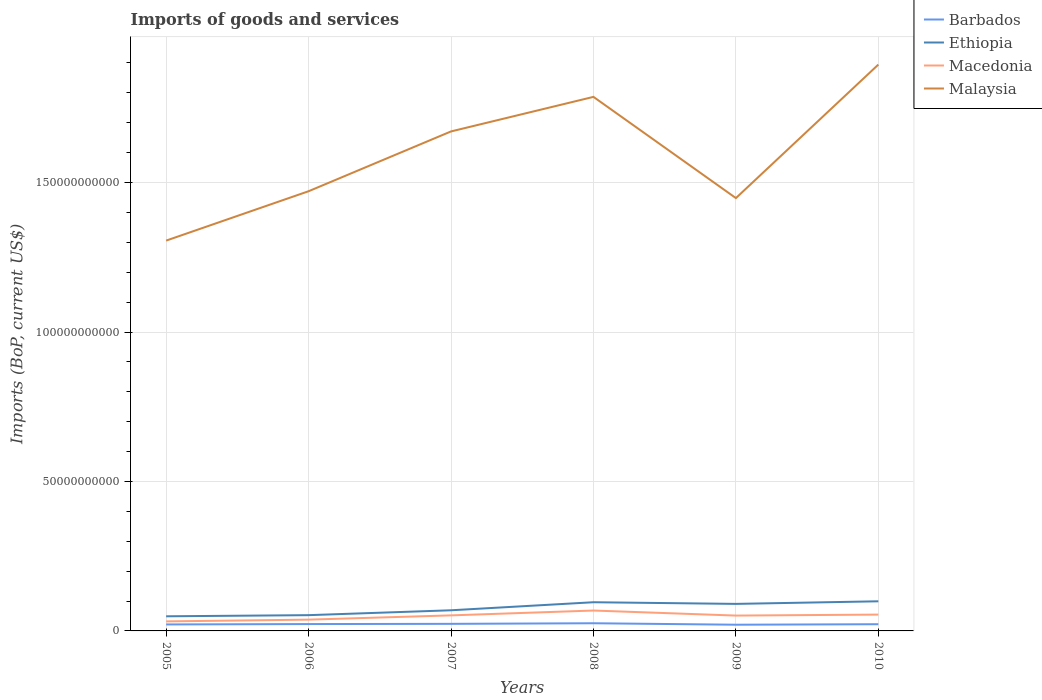How many different coloured lines are there?
Make the answer very short. 4. Does the line corresponding to Macedonia intersect with the line corresponding to Ethiopia?
Offer a terse response. No. Is the number of lines equal to the number of legend labels?
Make the answer very short. Yes. Across all years, what is the maximum amount spent on imports in Ethiopia?
Give a very brief answer. 4.89e+09. What is the total amount spent on imports in Malaysia in the graph?
Give a very brief answer. -2.00e+1. What is the difference between the highest and the second highest amount spent on imports in Malaysia?
Your answer should be compact. 5.89e+1. How many years are there in the graph?
Offer a very short reply. 6. What is the difference between two consecutive major ticks on the Y-axis?
Provide a short and direct response. 5.00e+1. Are the values on the major ticks of Y-axis written in scientific E-notation?
Make the answer very short. No. Does the graph contain any zero values?
Offer a very short reply. No. Does the graph contain grids?
Give a very brief answer. Yes. Where does the legend appear in the graph?
Provide a succinct answer. Top right. How many legend labels are there?
Keep it short and to the point. 4. What is the title of the graph?
Make the answer very short. Imports of goods and services. Does "Virgin Islands" appear as one of the legend labels in the graph?
Offer a very short reply. No. What is the label or title of the X-axis?
Offer a very short reply. Years. What is the label or title of the Y-axis?
Give a very brief answer. Imports (BoP, current US$). What is the Imports (BoP, current US$) in Barbados in 2005?
Your response must be concise. 2.17e+09. What is the Imports (BoP, current US$) in Ethiopia in 2005?
Your answer should be compact. 4.89e+09. What is the Imports (BoP, current US$) of Macedonia in 2005?
Ensure brevity in your answer.  3.19e+09. What is the Imports (BoP, current US$) of Malaysia in 2005?
Provide a short and direct response. 1.31e+11. What is the Imports (BoP, current US$) of Barbados in 2006?
Your answer should be very brief. 2.29e+09. What is the Imports (BoP, current US$) of Ethiopia in 2006?
Your answer should be compact. 5.28e+09. What is the Imports (BoP, current US$) of Macedonia in 2006?
Provide a short and direct response. 3.77e+09. What is the Imports (BoP, current US$) in Malaysia in 2006?
Your response must be concise. 1.47e+11. What is the Imports (BoP, current US$) of Barbados in 2007?
Your answer should be compact. 2.37e+09. What is the Imports (BoP, current US$) of Ethiopia in 2007?
Your response must be concise. 6.90e+09. What is the Imports (BoP, current US$) in Macedonia in 2007?
Provide a short and direct response. 5.20e+09. What is the Imports (BoP, current US$) of Malaysia in 2007?
Offer a very short reply. 1.67e+11. What is the Imports (BoP, current US$) of Barbados in 2008?
Provide a short and direct response. 2.57e+09. What is the Imports (BoP, current US$) of Ethiopia in 2008?
Keep it short and to the point. 9.60e+09. What is the Imports (BoP, current US$) of Macedonia in 2008?
Provide a succinct answer. 6.82e+09. What is the Imports (BoP, current US$) in Malaysia in 2008?
Your answer should be very brief. 1.79e+11. What is the Imports (BoP, current US$) of Barbados in 2009?
Offer a terse response. 2.08e+09. What is the Imports (BoP, current US$) in Ethiopia in 2009?
Offer a very short reply. 9.04e+09. What is the Imports (BoP, current US$) of Macedonia in 2009?
Provide a short and direct response. 5.13e+09. What is the Imports (BoP, current US$) of Malaysia in 2009?
Your response must be concise. 1.45e+11. What is the Imports (BoP, current US$) in Barbados in 2010?
Ensure brevity in your answer.  2.24e+09. What is the Imports (BoP, current US$) of Ethiopia in 2010?
Provide a succinct answer. 9.91e+09. What is the Imports (BoP, current US$) of Macedonia in 2010?
Make the answer very short. 5.46e+09. What is the Imports (BoP, current US$) in Malaysia in 2010?
Offer a very short reply. 1.89e+11. Across all years, what is the maximum Imports (BoP, current US$) in Barbados?
Your response must be concise. 2.57e+09. Across all years, what is the maximum Imports (BoP, current US$) in Ethiopia?
Provide a succinct answer. 9.91e+09. Across all years, what is the maximum Imports (BoP, current US$) of Macedonia?
Your answer should be compact. 6.82e+09. Across all years, what is the maximum Imports (BoP, current US$) in Malaysia?
Your response must be concise. 1.89e+11. Across all years, what is the minimum Imports (BoP, current US$) of Barbados?
Keep it short and to the point. 2.08e+09. Across all years, what is the minimum Imports (BoP, current US$) of Ethiopia?
Ensure brevity in your answer.  4.89e+09. Across all years, what is the minimum Imports (BoP, current US$) of Macedonia?
Ensure brevity in your answer.  3.19e+09. Across all years, what is the minimum Imports (BoP, current US$) in Malaysia?
Make the answer very short. 1.31e+11. What is the total Imports (BoP, current US$) in Barbados in the graph?
Offer a terse response. 1.37e+1. What is the total Imports (BoP, current US$) in Ethiopia in the graph?
Ensure brevity in your answer.  4.56e+1. What is the total Imports (BoP, current US$) of Macedonia in the graph?
Your answer should be very brief. 2.96e+1. What is the total Imports (BoP, current US$) in Malaysia in the graph?
Your answer should be compact. 9.58e+11. What is the difference between the Imports (BoP, current US$) in Barbados in 2005 and that in 2006?
Ensure brevity in your answer.  -1.23e+08. What is the difference between the Imports (BoP, current US$) of Ethiopia in 2005 and that in 2006?
Your answer should be very brief. -3.81e+08. What is the difference between the Imports (BoP, current US$) in Macedonia in 2005 and that in 2006?
Your answer should be very brief. -5.85e+08. What is the difference between the Imports (BoP, current US$) of Malaysia in 2005 and that in 2006?
Give a very brief answer. -1.65e+1. What is the difference between the Imports (BoP, current US$) of Barbados in 2005 and that in 2007?
Keep it short and to the point. -1.97e+08. What is the difference between the Imports (BoP, current US$) in Ethiopia in 2005 and that in 2007?
Give a very brief answer. -2.01e+09. What is the difference between the Imports (BoP, current US$) of Macedonia in 2005 and that in 2007?
Offer a very short reply. -2.01e+09. What is the difference between the Imports (BoP, current US$) of Malaysia in 2005 and that in 2007?
Keep it short and to the point. -3.65e+1. What is the difference between the Imports (BoP, current US$) of Barbados in 2005 and that in 2008?
Your answer should be very brief. -3.97e+08. What is the difference between the Imports (BoP, current US$) of Ethiopia in 2005 and that in 2008?
Your answer should be very brief. -4.70e+09. What is the difference between the Imports (BoP, current US$) of Macedonia in 2005 and that in 2008?
Your answer should be very brief. -3.63e+09. What is the difference between the Imports (BoP, current US$) in Malaysia in 2005 and that in 2008?
Ensure brevity in your answer.  -4.81e+1. What is the difference between the Imports (BoP, current US$) in Barbados in 2005 and that in 2009?
Ensure brevity in your answer.  9.44e+07. What is the difference between the Imports (BoP, current US$) in Ethiopia in 2005 and that in 2009?
Your answer should be compact. -4.15e+09. What is the difference between the Imports (BoP, current US$) in Macedonia in 2005 and that in 2009?
Offer a terse response. -1.94e+09. What is the difference between the Imports (BoP, current US$) of Malaysia in 2005 and that in 2009?
Provide a short and direct response. -1.42e+1. What is the difference between the Imports (BoP, current US$) of Barbados in 2005 and that in 2010?
Provide a succinct answer. -6.91e+07. What is the difference between the Imports (BoP, current US$) of Ethiopia in 2005 and that in 2010?
Give a very brief answer. -5.02e+09. What is the difference between the Imports (BoP, current US$) in Macedonia in 2005 and that in 2010?
Your response must be concise. -2.28e+09. What is the difference between the Imports (BoP, current US$) in Malaysia in 2005 and that in 2010?
Your answer should be very brief. -5.89e+1. What is the difference between the Imports (BoP, current US$) of Barbados in 2006 and that in 2007?
Your answer should be very brief. -7.39e+07. What is the difference between the Imports (BoP, current US$) of Ethiopia in 2006 and that in 2007?
Your answer should be very brief. -1.63e+09. What is the difference between the Imports (BoP, current US$) of Macedonia in 2006 and that in 2007?
Ensure brevity in your answer.  -1.43e+09. What is the difference between the Imports (BoP, current US$) of Malaysia in 2006 and that in 2007?
Provide a succinct answer. -2.00e+1. What is the difference between the Imports (BoP, current US$) of Barbados in 2006 and that in 2008?
Your answer should be very brief. -2.74e+08. What is the difference between the Imports (BoP, current US$) of Ethiopia in 2006 and that in 2008?
Your answer should be very brief. -4.32e+09. What is the difference between the Imports (BoP, current US$) of Macedonia in 2006 and that in 2008?
Provide a short and direct response. -3.05e+09. What is the difference between the Imports (BoP, current US$) of Malaysia in 2006 and that in 2008?
Provide a succinct answer. -3.16e+1. What is the difference between the Imports (BoP, current US$) in Barbados in 2006 and that in 2009?
Your answer should be compact. 2.17e+08. What is the difference between the Imports (BoP, current US$) in Ethiopia in 2006 and that in 2009?
Provide a succinct answer. -3.77e+09. What is the difference between the Imports (BoP, current US$) of Macedonia in 2006 and that in 2009?
Your answer should be very brief. -1.36e+09. What is the difference between the Imports (BoP, current US$) of Malaysia in 2006 and that in 2009?
Your answer should be compact. 2.30e+09. What is the difference between the Imports (BoP, current US$) of Barbados in 2006 and that in 2010?
Keep it short and to the point. 5.40e+07. What is the difference between the Imports (BoP, current US$) of Ethiopia in 2006 and that in 2010?
Keep it short and to the point. -4.63e+09. What is the difference between the Imports (BoP, current US$) in Macedonia in 2006 and that in 2010?
Provide a short and direct response. -1.69e+09. What is the difference between the Imports (BoP, current US$) in Malaysia in 2006 and that in 2010?
Your response must be concise. -4.24e+1. What is the difference between the Imports (BoP, current US$) in Barbados in 2007 and that in 2008?
Your answer should be compact. -2.00e+08. What is the difference between the Imports (BoP, current US$) of Ethiopia in 2007 and that in 2008?
Your response must be concise. -2.69e+09. What is the difference between the Imports (BoP, current US$) of Macedonia in 2007 and that in 2008?
Offer a very short reply. -1.62e+09. What is the difference between the Imports (BoP, current US$) of Malaysia in 2007 and that in 2008?
Provide a short and direct response. -1.16e+1. What is the difference between the Imports (BoP, current US$) of Barbados in 2007 and that in 2009?
Your response must be concise. 2.91e+08. What is the difference between the Imports (BoP, current US$) of Ethiopia in 2007 and that in 2009?
Provide a short and direct response. -2.14e+09. What is the difference between the Imports (BoP, current US$) in Macedonia in 2007 and that in 2009?
Offer a terse response. 6.79e+07. What is the difference between the Imports (BoP, current US$) in Malaysia in 2007 and that in 2009?
Provide a short and direct response. 2.23e+1. What is the difference between the Imports (BoP, current US$) of Barbados in 2007 and that in 2010?
Your response must be concise. 1.28e+08. What is the difference between the Imports (BoP, current US$) in Ethiopia in 2007 and that in 2010?
Offer a terse response. -3.01e+09. What is the difference between the Imports (BoP, current US$) in Macedonia in 2007 and that in 2010?
Ensure brevity in your answer.  -2.63e+08. What is the difference between the Imports (BoP, current US$) of Malaysia in 2007 and that in 2010?
Provide a succinct answer. -2.24e+1. What is the difference between the Imports (BoP, current US$) of Barbados in 2008 and that in 2009?
Ensure brevity in your answer.  4.92e+08. What is the difference between the Imports (BoP, current US$) in Ethiopia in 2008 and that in 2009?
Offer a very short reply. 5.55e+08. What is the difference between the Imports (BoP, current US$) of Macedonia in 2008 and that in 2009?
Offer a terse response. 1.69e+09. What is the difference between the Imports (BoP, current US$) of Malaysia in 2008 and that in 2009?
Provide a short and direct response. 3.39e+1. What is the difference between the Imports (BoP, current US$) in Barbados in 2008 and that in 2010?
Give a very brief answer. 3.28e+08. What is the difference between the Imports (BoP, current US$) in Ethiopia in 2008 and that in 2010?
Your answer should be very brief. -3.13e+08. What is the difference between the Imports (BoP, current US$) of Macedonia in 2008 and that in 2010?
Keep it short and to the point. 1.36e+09. What is the difference between the Imports (BoP, current US$) of Malaysia in 2008 and that in 2010?
Make the answer very short. -1.08e+1. What is the difference between the Imports (BoP, current US$) of Barbados in 2009 and that in 2010?
Your response must be concise. -1.63e+08. What is the difference between the Imports (BoP, current US$) of Ethiopia in 2009 and that in 2010?
Provide a succinct answer. -8.68e+08. What is the difference between the Imports (BoP, current US$) of Macedonia in 2009 and that in 2010?
Make the answer very short. -3.31e+08. What is the difference between the Imports (BoP, current US$) in Malaysia in 2009 and that in 2010?
Provide a short and direct response. -4.47e+1. What is the difference between the Imports (BoP, current US$) in Barbados in 2005 and the Imports (BoP, current US$) in Ethiopia in 2006?
Provide a short and direct response. -3.10e+09. What is the difference between the Imports (BoP, current US$) in Barbados in 2005 and the Imports (BoP, current US$) in Macedonia in 2006?
Offer a very short reply. -1.60e+09. What is the difference between the Imports (BoP, current US$) in Barbados in 2005 and the Imports (BoP, current US$) in Malaysia in 2006?
Ensure brevity in your answer.  -1.45e+11. What is the difference between the Imports (BoP, current US$) of Ethiopia in 2005 and the Imports (BoP, current US$) of Macedonia in 2006?
Offer a terse response. 1.12e+09. What is the difference between the Imports (BoP, current US$) of Ethiopia in 2005 and the Imports (BoP, current US$) of Malaysia in 2006?
Your answer should be very brief. -1.42e+11. What is the difference between the Imports (BoP, current US$) of Macedonia in 2005 and the Imports (BoP, current US$) of Malaysia in 2006?
Provide a short and direct response. -1.44e+11. What is the difference between the Imports (BoP, current US$) of Barbados in 2005 and the Imports (BoP, current US$) of Ethiopia in 2007?
Your answer should be very brief. -4.73e+09. What is the difference between the Imports (BoP, current US$) in Barbados in 2005 and the Imports (BoP, current US$) in Macedonia in 2007?
Your answer should be very brief. -3.03e+09. What is the difference between the Imports (BoP, current US$) in Barbados in 2005 and the Imports (BoP, current US$) in Malaysia in 2007?
Make the answer very short. -1.65e+11. What is the difference between the Imports (BoP, current US$) of Ethiopia in 2005 and the Imports (BoP, current US$) of Macedonia in 2007?
Make the answer very short. -3.05e+08. What is the difference between the Imports (BoP, current US$) of Ethiopia in 2005 and the Imports (BoP, current US$) of Malaysia in 2007?
Make the answer very short. -1.62e+11. What is the difference between the Imports (BoP, current US$) of Macedonia in 2005 and the Imports (BoP, current US$) of Malaysia in 2007?
Your answer should be compact. -1.64e+11. What is the difference between the Imports (BoP, current US$) in Barbados in 2005 and the Imports (BoP, current US$) in Ethiopia in 2008?
Provide a short and direct response. -7.43e+09. What is the difference between the Imports (BoP, current US$) of Barbados in 2005 and the Imports (BoP, current US$) of Macedonia in 2008?
Provide a short and direct response. -4.65e+09. What is the difference between the Imports (BoP, current US$) in Barbados in 2005 and the Imports (BoP, current US$) in Malaysia in 2008?
Keep it short and to the point. -1.76e+11. What is the difference between the Imports (BoP, current US$) of Ethiopia in 2005 and the Imports (BoP, current US$) of Macedonia in 2008?
Ensure brevity in your answer.  -1.92e+09. What is the difference between the Imports (BoP, current US$) in Ethiopia in 2005 and the Imports (BoP, current US$) in Malaysia in 2008?
Offer a terse response. -1.74e+11. What is the difference between the Imports (BoP, current US$) in Macedonia in 2005 and the Imports (BoP, current US$) in Malaysia in 2008?
Your answer should be very brief. -1.75e+11. What is the difference between the Imports (BoP, current US$) in Barbados in 2005 and the Imports (BoP, current US$) in Ethiopia in 2009?
Provide a short and direct response. -6.87e+09. What is the difference between the Imports (BoP, current US$) of Barbados in 2005 and the Imports (BoP, current US$) of Macedonia in 2009?
Provide a succinct answer. -2.96e+09. What is the difference between the Imports (BoP, current US$) of Barbados in 2005 and the Imports (BoP, current US$) of Malaysia in 2009?
Your answer should be compact. -1.43e+11. What is the difference between the Imports (BoP, current US$) of Ethiopia in 2005 and the Imports (BoP, current US$) of Macedonia in 2009?
Your answer should be compact. -2.37e+08. What is the difference between the Imports (BoP, current US$) of Ethiopia in 2005 and the Imports (BoP, current US$) of Malaysia in 2009?
Give a very brief answer. -1.40e+11. What is the difference between the Imports (BoP, current US$) in Macedonia in 2005 and the Imports (BoP, current US$) in Malaysia in 2009?
Provide a short and direct response. -1.42e+11. What is the difference between the Imports (BoP, current US$) of Barbados in 2005 and the Imports (BoP, current US$) of Ethiopia in 2010?
Provide a succinct answer. -7.74e+09. What is the difference between the Imports (BoP, current US$) in Barbados in 2005 and the Imports (BoP, current US$) in Macedonia in 2010?
Offer a very short reply. -3.29e+09. What is the difference between the Imports (BoP, current US$) of Barbados in 2005 and the Imports (BoP, current US$) of Malaysia in 2010?
Ensure brevity in your answer.  -1.87e+11. What is the difference between the Imports (BoP, current US$) of Ethiopia in 2005 and the Imports (BoP, current US$) of Macedonia in 2010?
Offer a very short reply. -5.69e+08. What is the difference between the Imports (BoP, current US$) in Ethiopia in 2005 and the Imports (BoP, current US$) in Malaysia in 2010?
Provide a short and direct response. -1.85e+11. What is the difference between the Imports (BoP, current US$) of Macedonia in 2005 and the Imports (BoP, current US$) of Malaysia in 2010?
Ensure brevity in your answer.  -1.86e+11. What is the difference between the Imports (BoP, current US$) in Barbados in 2006 and the Imports (BoP, current US$) in Ethiopia in 2007?
Offer a very short reply. -4.61e+09. What is the difference between the Imports (BoP, current US$) of Barbados in 2006 and the Imports (BoP, current US$) of Macedonia in 2007?
Offer a terse response. -2.91e+09. What is the difference between the Imports (BoP, current US$) of Barbados in 2006 and the Imports (BoP, current US$) of Malaysia in 2007?
Your answer should be very brief. -1.65e+11. What is the difference between the Imports (BoP, current US$) of Ethiopia in 2006 and the Imports (BoP, current US$) of Macedonia in 2007?
Your answer should be very brief. 7.60e+07. What is the difference between the Imports (BoP, current US$) of Ethiopia in 2006 and the Imports (BoP, current US$) of Malaysia in 2007?
Your answer should be compact. -1.62e+11. What is the difference between the Imports (BoP, current US$) of Macedonia in 2006 and the Imports (BoP, current US$) of Malaysia in 2007?
Give a very brief answer. -1.63e+11. What is the difference between the Imports (BoP, current US$) in Barbados in 2006 and the Imports (BoP, current US$) in Ethiopia in 2008?
Offer a very short reply. -7.30e+09. What is the difference between the Imports (BoP, current US$) in Barbados in 2006 and the Imports (BoP, current US$) in Macedonia in 2008?
Ensure brevity in your answer.  -4.53e+09. What is the difference between the Imports (BoP, current US$) in Barbados in 2006 and the Imports (BoP, current US$) in Malaysia in 2008?
Provide a succinct answer. -1.76e+11. What is the difference between the Imports (BoP, current US$) of Ethiopia in 2006 and the Imports (BoP, current US$) of Macedonia in 2008?
Keep it short and to the point. -1.54e+09. What is the difference between the Imports (BoP, current US$) in Ethiopia in 2006 and the Imports (BoP, current US$) in Malaysia in 2008?
Keep it short and to the point. -1.73e+11. What is the difference between the Imports (BoP, current US$) of Macedonia in 2006 and the Imports (BoP, current US$) of Malaysia in 2008?
Make the answer very short. -1.75e+11. What is the difference between the Imports (BoP, current US$) in Barbados in 2006 and the Imports (BoP, current US$) in Ethiopia in 2009?
Make the answer very short. -6.75e+09. What is the difference between the Imports (BoP, current US$) of Barbados in 2006 and the Imports (BoP, current US$) of Macedonia in 2009?
Offer a very short reply. -2.84e+09. What is the difference between the Imports (BoP, current US$) of Barbados in 2006 and the Imports (BoP, current US$) of Malaysia in 2009?
Keep it short and to the point. -1.43e+11. What is the difference between the Imports (BoP, current US$) in Ethiopia in 2006 and the Imports (BoP, current US$) in Macedonia in 2009?
Keep it short and to the point. 1.44e+08. What is the difference between the Imports (BoP, current US$) in Ethiopia in 2006 and the Imports (BoP, current US$) in Malaysia in 2009?
Your answer should be compact. -1.40e+11. What is the difference between the Imports (BoP, current US$) in Macedonia in 2006 and the Imports (BoP, current US$) in Malaysia in 2009?
Your answer should be very brief. -1.41e+11. What is the difference between the Imports (BoP, current US$) in Barbados in 2006 and the Imports (BoP, current US$) in Ethiopia in 2010?
Your answer should be compact. -7.62e+09. What is the difference between the Imports (BoP, current US$) of Barbados in 2006 and the Imports (BoP, current US$) of Macedonia in 2010?
Your answer should be compact. -3.17e+09. What is the difference between the Imports (BoP, current US$) in Barbados in 2006 and the Imports (BoP, current US$) in Malaysia in 2010?
Make the answer very short. -1.87e+11. What is the difference between the Imports (BoP, current US$) in Ethiopia in 2006 and the Imports (BoP, current US$) in Macedonia in 2010?
Make the answer very short. -1.87e+08. What is the difference between the Imports (BoP, current US$) of Ethiopia in 2006 and the Imports (BoP, current US$) of Malaysia in 2010?
Your response must be concise. -1.84e+11. What is the difference between the Imports (BoP, current US$) of Macedonia in 2006 and the Imports (BoP, current US$) of Malaysia in 2010?
Provide a short and direct response. -1.86e+11. What is the difference between the Imports (BoP, current US$) of Barbados in 2007 and the Imports (BoP, current US$) of Ethiopia in 2008?
Provide a short and direct response. -7.23e+09. What is the difference between the Imports (BoP, current US$) of Barbados in 2007 and the Imports (BoP, current US$) of Macedonia in 2008?
Your answer should be very brief. -4.45e+09. What is the difference between the Imports (BoP, current US$) in Barbados in 2007 and the Imports (BoP, current US$) in Malaysia in 2008?
Ensure brevity in your answer.  -1.76e+11. What is the difference between the Imports (BoP, current US$) in Ethiopia in 2007 and the Imports (BoP, current US$) in Macedonia in 2008?
Your answer should be very brief. 8.50e+07. What is the difference between the Imports (BoP, current US$) in Ethiopia in 2007 and the Imports (BoP, current US$) in Malaysia in 2008?
Your response must be concise. -1.72e+11. What is the difference between the Imports (BoP, current US$) in Macedonia in 2007 and the Imports (BoP, current US$) in Malaysia in 2008?
Your answer should be very brief. -1.73e+11. What is the difference between the Imports (BoP, current US$) of Barbados in 2007 and the Imports (BoP, current US$) of Ethiopia in 2009?
Your answer should be very brief. -6.67e+09. What is the difference between the Imports (BoP, current US$) of Barbados in 2007 and the Imports (BoP, current US$) of Macedonia in 2009?
Your answer should be very brief. -2.76e+09. What is the difference between the Imports (BoP, current US$) in Barbados in 2007 and the Imports (BoP, current US$) in Malaysia in 2009?
Ensure brevity in your answer.  -1.42e+11. What is the difference between the Imports (BoP, current US$) of Ethiopia in 2007 and the Imports (BoP, current US$) of Macedonia in 2009?
Keep it short and to the point. 1.77e+09. What is the difference between the Imports (BoP, current US$) of Ethiopia in 2007 and the Imports (BoP, current US$) of Malaysia in 2009?
Your answer should be very brief. -1.38e+11. What is the difference between the Imports (BoP, current US$) in Macedonia in 2007 and the Imports (BoP, current US$) in Malaysia in 2009?
Make the answer very short. -1.40e+11. What is the difference between the Imports (BoP, current US$) in Barbados in 2007 and the Imports (BoP, current US$) in Ethiopia in 2010?
Keep it short and to the point. -7.54e+09. What is the difference between the Imports (BoP, current US$) in Barbados in 2007 and the Imports (BoP, current US$) in Macedonia in 2010?
Provide a short and direct response. -3.10e+09. What is the difference between the Imports (BoP, current US$) of Barbados in 2007 and the Imports (BoP, current US$) of Malaysia in 2010?
Ensure brevity in your answer.  -1.87e+11. What is the difference between the Imports (BoP, current US$) in Ethiopia in 2007 and the Imports (BoP, current US$) in Macedonia in 2010?
Offer a terse response. 1.44e+09. What is the difference between the Imports (BoP, current US$) in Ethiopia in 2007 and the Imports (BoP, current US$) in Malaysia in 2010?
Your answer should be compact. -1.83e+11. What is the difference between the Imports (BoP, current US$) of Macedonia in 2007 and the Imports (BoP, current US$) of Malaysia in 2010?
Give a very brief answer. -1.84e+11. What is the difference between the Imports (BoP, current US$) of Barbados in 2008 and the Imports (BoP, current US$) of Ethiopia in 2009?
Give a very brief answer. -6.47e+09. What is the difference between the Imports (BoP, current US$) of Barbados in 2008 and the Imports (BoP, current US$) of Macedonia in 2009?
Provide a succinct answer. -2.56e+09. What is the difference between the Imports (BoP, current US$) of Barbados in 2008 and the Imports (BoP, current US$) of Malaysia in 2009?
Provide a succinct answer. -1.42e+11. What is the difference between the Imports (BoP, current US$) in Ethiopia in 2008 and the Imports (BoP, current US$) in Macedonia in 2009?
Your answer should be very brief. 4.47e+09. What is the difference between the Imports (BoP, current US$) in Ethiopia in 2008 and the Imports (BoP, current US$) in Malaysia in 2009?
Make the answer very short. -1.35e+11. What is the difference between the Imports (BoP, current US$) in Macedonia in 2008 and the Imports (BoP, current US$) in Malaysia in 2009?
Your response must be concise. -1.38e+11. What is the difference between the Imports (BoP, current US$) of Barbados in 2008 and the Imports (BoP, current US$) of Ethiopia in 2010?
Offer a very short reply. -7.34e+09. What is the difference between the Imports (BoP, current US$) of Barbados in 2008 and the Imports (BoP, current US$) of Macedonia in 2010?
Make the answer very short. -2.89e+09. What is the difference between the Imports (BoP, current US$) of Barbados in 2008 and the Imports (BoP, current US$) of Malaysia in 2010?
Provide a short and direct response. -1.87e+11. What is the difference between the Imports (BoP, current US$) in Ethiopia in 2008 and the Imports (BoP, current US$) in Macedonia in 2010?
Keep it short and to the point. 4.13e+09. What is the difference between the Imports (BoP, current US$) in Ethiopia in 2008 and the Imports (BoP, current US$) in Malaysia in 2010?
Your response must be concise. -1.80e+11. What is the difference between the Imports (BoP, current US$) of Macedonia in 2008 and the Imports (BoP, current US$) of Malaysia in 2010?
Provide a succinct answer. -1.83e+11. What is the difference between the Imports (BoP, current US$) of Barbados in 2009 and the Imports (BoP, current US$) of Ethiopia in 2010?
Provide a short and direct response. -7.83e+09. What is the difference between the Imports (BoP, current US$) in Barbados in 2009 and the Imports (BoP, current US$) in Macedonia in 2010?
Your answer should be compact. -3.39e+09. What is the difference between the Imports (BoP, current US$) in Barbados in 2009 and the Imports (BoP, current US$) in Malaysia in 2010?
Keep it short and to the point. -1.87e+11. What is the difference between the Imports (BoP, current US$) in Ethiopia in 2009 and the Imports (BoP, current US$) in Macedonia in 2010?
Keep it short and to the point. 3.58e+09. What is the difference between the Imports (BoP, current US$) in Ethiopia in 2009 and the Imports (BoP, current US$) in Malaysia in 2010?
Your answer should be compact. -1.80e+11. What is the difference between the Imports (BoP, current US$) of Macedonia in 2009 and the Imports (BoP, current US$) of Malaysia in 2010?
Your answer should be compact. -1.84e+11. What is the average Imports (BoP, current US$) of Barbados per year?
Your answer should be compact. 2.29e+09. What is the average Imports (BoP, current US$) in Ethiopia per year?
Ensure brevity in your answer.  7.60e+09. What is the average Imports (BoP, current US$) in Macedonia per year?
Offer a terse response. 4.93e+09. What is the average Imports (BoP, current US$) in Malaysia per year?
Provide a succinct answer. 1.60e+11. In the year 2005, what is the difference between the Imports (BoP, current US$) in Barbados and Imports (BoP, current US$) in Ethiopia?
Your answer should be compact. -2.72e+09. In the year 2005, what is the difference between the Imports (BoP, current US$) in Barbados and Imports (BoP, current US$) in Macedonia?
Keep it short and to the point. -1.02e+09. In the year 2005, what is the difference between the Imports (BoP, current US$) of Barbados and Imports (BoP, current US$) of Malaysia?
Offer a very short reply. -1.28e+11. In the year 2005, what is the difference between the Imports (BoP, current US$) of Ethiopia and Imports (BoP, current US$) of Macedonia?
Your response must be concise. 1.71e+09. In the year 2005, what is the difference between the Imports (BoP, current US$) in Ethiopia and Imports (BoP, current US$) in Malaysia?
Your response must be concise. -1.26e+11. In the year 2005, what is the difference between the Imports (BoP, current US$) in Macedonia and Imports (BoP, current US$) in Malaysia?
Your response must be concise. -1.27e+11. In the year 2006, what is the difference between the Imports (BoP, current US$) in Barbados and Imports (BoP, current US$) in Ethiopia?
Ensure brevity in your answer.  -2.98e+09. In the year 2006, what is the difference between the Imports (BoP, current US$) of Barbados and Imports (BoP, current US$) of Macedonia?
Your answer should be compact. -1.48e+09. In the year 2006, what is the difference between the Imports (BoP, current US$) of Barbados and Imports (BoP, current US$) of Malaysia?
Offer a terse response. -1.45e+11. In the year 2006, what is the difference between the Imports (BoP, current US$) of Ethiopia and Imports (BoP, current US$) of Macedonia?
Your response must be concise. 1.50e+09. In the year 2006, what is the difference between the Imports (BoP, current US$) in Ethiopia and Imports (BoP, current US$) in Malaysia?
Make the answer very short. -1.42e+11. In the year 2006, what is the difference between the Imports (BoP, current US$) of Macedonia and Imports (BoP, current US$) of Malaysia?
Ensure brevity in your answer.  -1.43e+11. In the year 2007, what is the difference between the Imports (BoP, current US$) in Barbados and Imports (BoP, current US$) in Ethiopia?
Your answer should be very brief. -4.54e+09. In the year 2007, what is the difference between the Imports (BoP, current US$) in Barbados and Imports (BoP, current US$) in Macedonia?
Provide a short and direct response. -2.83e+09. In the year 2007, what is the difference between the Imports (BoP, current US$) in Barbados and Imports (BoP, current US$) in Malaysia?
Your response must be concise. -1.65e+11. In the year 2007, what is the difference between the Imports (BoP, current US$) of Ethiopia and Imports (BoP, current US$) of Macedonia?
Offer a terse response. 1.70e+09. In the year 2007, what is the difference between the Imports (BoP, current US$) in Ethiopia and Imports (BoP, current US$) in Malaysia?
Your answer should be compact. -1.60e+11. In the year 2007, what is the difference between the Imports (BoP, current US$) of Macedonia and Imports (BoP, current US$) of Malaysia?
Provide a short and direct response. -1.62e+11. In the year 2008, what is the difference between the Imports (BoP, current US$) of Barbados and Imports (BoP, current US$) of Ethiopia?
Provide a succinct answer. -7.03e+09. In the year 2008, what is the difference between the Imports (BoP, current US$) in Barbados and Imports (BoP, current US$) in Macedonia?
Offer a very short reply. -4.25e+09. In the year 2008, what is the difference between the Imports (BoP, current US$) of Barbados and Imports (BoP, current US$) of Malaysia?
Your response must be concise. -1.76e+11. In the year 2008, what is the difference between the Imports (BoP, current US$) in Ethiopia and Imports (BoP, current US$) in Macedonia?
Make the answer very short. 2.78e+09. In the year 2008, what is the difference between the Imports (BoP, current US$) of Ethiopia and Imports (BoP, current US$) of Malaysia?
Your response must be concise. -1.69e+11. In the year 2008, what is the difference between the Imports (BoP, current US$) of Macedonia and Imports (BoP, current US$) of Malaysia?
Make the answer very short. -1.72e+11. In the year 2009, what is the difference between the Imports (BoP, current US$) in Barbados and Imports (BoP, current US$) in Ethiopia?
Your answer should be very brief. -6.97e+09. In the year 2009, what is the difference between the Imports (BoP, current US$) of Barbados and Imports (BoP, current US$) of Macedonia?
Your answer should be compact. -3.06e+09. In the year 2009, what is the difference between the Imports (BoP, current US$) of Barbados and Imports (BoP, current US$) of Malaysia?
Provide a succinct answer. -1.43e+11. In the year 2009, what is the difference between the Imports (BoP, current US$) in Ethiopia and Imports (BoP, current US$) in Macedonia?
Your answer should be very brief. 3.91e+09. In the year 2009, what is the difference between the Imports (BoP, current US$) of Ethiopia and Imports (BoP, current US$) of Malaysia?
Your response must be concise. -1.36e+11. In the year 2009, what is the difference between the Imports (BoP, current US$) in Macedonia and Imports (BoP, current US$) in Malaysia?
Your answer should be very brief. -1.40e+11. In the year 2010, what is the difference between the Imports (BoP, current US$) in Barbados and Imports (BoP, current US$) in Ethiopia?
Keep it short and to the point. -7.67e+09. In the year 2010, what is the difference between the Imports (BoP, current US$) of Barbados and Imports (BoP, current US$) of Macedonia?
Provide a short and direct response. -3.22e+09. In the year 2010, what is the difference between the Imports (BoP, current US$) in Barbados and Imports (BoP, current US$) in Malaysia?
Your response must be concise. -1.87e+11. In the year 2010, what is the difference between the Imports (BoP, current US$) in Ethiopia and Imports (BoP, current US$) in Macedonia?
Provide a succinct answer. 4.45e+09. In the year 2010, what is the difference between the Imports (BoP, current US$) of Ethiopia and Imports (BoP, current US$) of Malaysia?
Keep it short and to the point. -1.80e+11. In the year 2010, what is the difference between the Imports (BoP, current US$) in Macedonia and Imports (BoP, current US$) in Malaysia?
Your answer should be very brief. -1.84e+11. What is the ratio of the Imports (BoP, current US$) of Barbados in 2005 to that in 2006?
Provide a succinct answer. 0.95. What is the ratio of the Imports (BoP, current US$) in Ethiopia in 2005 to that in 2006?
Your answer should be very brief. 0.93. What is the ratio of the Imports (BoP, current US$) in Macedonia in 2005 to that in 2006?
Your response must be concise. 0.84. What is the ratio of the Imports (BoP, current US$) of Malaysia in 2005 to that in 2006?
Your answer should be very brief. 0.89. What is the ratio of the Imports (BoP, current US$) in Barbados in 2005 to that in 2007?
Your answer should be compact. 0.92. What is the ratio of the Imports (BoP, current US$) in Ethiopia in 2005 to that in 2007?
Your response must be concise. 0.71. What is the ratio of the Imports (BoP, current US$) in Macedonia in 2005 to that in 2007?
Offer a terse response. 0.61. What is the ratio of the Imports (BoP, current US$) in Malaysia in 2005 to that in 2007?
Give a very brief answer. 0.78. What is the ratio of the Imports (BoP, current US$) of Barbados in 2005 to that in 2008?
Offer a terse response. 0.85. What is the ratio of the Imports (BoP, current US$) of Ethiopia in 2005 to that in 2008?
Make the answer very short. 0.51. What is the ratio of the Imports (BoP, current US$) of Macedonia in 2005 to that in 2008?
Give a very brief answer. 0.47. What is the ratio of the Imports (BoP, current US$) in Malaysia in 2005 to that in 2008?
Give a very brief answer. 0.73. What is the ratio of the Imports (BoP, current US$) in Barbados in 2005 to that in 2009?
Your answer should be compact. 1.05. What is the ratio of the Imports (BoP, current US$) in Ethiopia in 2005 to that in 2009?
Your answer should be very brief. 0.54. What is the ratio of the Imports (BoP, current US$) in Macedonia in 2005 to that in 2009?
Provide a succinct answer. 0.62. What is the ratio of the Imports (BoP, current US$) in Malaysia in 2005 to that in 2009?
Provide a short and direct response. 0.9. What is the ratio of the Imports (BoP, current US$) in Barbados in 2005 to that in 2010?
Offer a very short reply. 0.97. What is the ratio of the Imports (BoP, current US$) of Ethiopia in 2005 to that in 2010?
Ensure brevity in your answer.  0.49. What is the ratio of the Imports (BoP, current US$) of Macedonia in 2005 to that in 2010?
Your answer should be very brief. 0.58. What is the ratio of the Imports (BoP, current US$) of Malaysia in 2005 to that in 2010?
Provide a succinct answer. 0.69. What is the ratio of the Imports (BoP, current US$) of Barbados in 2006 to that in 2007?
Your response must be concise. 0.97. What is the ratio of the Imports (BoP, current US$) of Ethiopia in 2006 to that in 2007?
Keep it short and to the point. 0.76. What is the ratio of the Imports (BoP, current US$) of Macedonia in 2006 to that in 2007?
Ensure brevity in your answer.  0.73. What is the ratio of the Imports (BoP, current US$) in Malaysia in 2006 to that in 2007?
Provide a succinct answer. 0.88. What is the ratio of the Imports (BoP, current US$) in Barbados in 2006 to that in 2008?
Give a very brief answer. 0.89. What is the ratio of the Imports (BoP, current US$) in Ethiopia in 2006 to that in 2008?
Provide a succinct answer. 0.55. What is the ratio of the Imports (BoP, current US$) of Macedonia in 2006 to that in 2008?
Ensure brevity in your answer.  0.55. What is the ratio of the Imports (BoP, current US$) in Malaysia in 2006 to that in 2008?
Give a very brief answer. 0.82. What is the ratio of the Imports (BoP, current US$) of Barbados in 2006 to that in 2009?
Offer a terse response. 1.1. What is the ratio of the Imports (BoP, current US$) of Ethiopia in 2006 to that in 2009?
Offer a very short reply. 0.58. What is the ratio of the Imports (BoP, current US$) in Macedonia in 2006 to that in 2009?
Your response must be concise. 0.73. What is the ratio of the Imports (BoP, current US$) in Malaysia in 2006 to that in 2009?
Offer a very short reply. 1.02. What is the ratio of the Imports (BoP, current US$) of Barbados in 2006 to that in 2010?
Provide a succinct answer. 1.02. What is the ratio of the Imports (BoP, current US$) of Ethiopia in 2006 to that in 2010?
Your response must be concise. 0.53. What is the ratio of the Imports (BoP, current US$) in Macedonia in 2006 to that in 2010?
Your answer should be compact. 0.69. What is the ratio of the Imports (BoP, current US$) in Malaysia in 2006 to that in 2010?
Your answer should be very brief. 0.78. What is the ratio of the Imports (BoP, current US$) of Barbados in 2007 to that in 2008?
Your answer should be very brief. 0.92. What is the ratio of the Imports (BoP, current US$) of Ethiopia in 2007 to that in 2008?
Keep it short and to the point. 0.72. What is the ratio of the Imports (BoP, current US$) of Macedonia in 2007 to that in 2008?
Your response must be concise. 0.76. What is the ratio of the Imports (BoP, current US$) in Malaysia in 2007 to that in 2008?
Your response must be concise. 0.94. What is the ratio of the Imports (BoP, current US$) in Barbados in 2007 to that in 2009?
Give a very brief answer. 1.14. What is the ratio of the Imports (BoP, current US$) of Ethiopia in 2007 to that in 2009?
Provide a short and direct response. 0.76. What is the ratio of the Imports (BoP, current US$) in Macedonia in 2007 to that in 2009?
Provide a short and direct response. 1.01. What is the ratio of the Imports (BoP, current US$) in Malaysia in 2007 to that in 2009?
Ensure brevity in your answer.  1.15. What is the ratio of the Imports (BoP, current US$) in Barbados in 2007 to that in 2010?
Provide a succinct answer. 1.06. What is the ratio of the Imports (BoP, current US$) in Ethiopia in 2007 to that in 2010?
Give a very brief answer. 0.7. What is the ratio of the Imports (BoP, current US$) in Macedonia in 2007 to that in 2010?
Give a very brief answer. 0.95. What is the ratio of the Imports (BoP, current US$) in Malaysia in 2007 to that in 2010?
Keep it short and to the point. 0.88. What is the ratio of the Imports (BoP, current US$) in Barbados in 2008 to that in 2009?
Your response must be concise. 1.24. What is the ratio of the Imports (BoP, current US$) of Ethiopia in 2008 to that in 2009?
Your response must be concise. 1.06. What is the ratio of the Imports (BoP, current US$) in Macedonia in 2008 to that in 2009?
Offer a terse response. 1.33. What is the ratio of the Imports (BoP, current US$) in Malaysia in 2008 to that in 2009?
Keep it short and to the point. 1.23. What is the ratio of the Imports (BoP, current US$) in Barbados in 2008 to that in 2010?
Keep it short and to the point. 1.15. What is the ratio of the Imports (BoP, current US$) of Ethiopia in 2008 to that in 2010?
Your answer should be very brief. 0.97. What is the ratio of the Imports (BoP, current US$) of Macedonia in 2008 to that in 2010?
Ensure brevity in your answer.  1.25. What is the ratio of the Imports (BoP, current US$) of Malaysia in 2008 to that in 2010?
Make the answer very short. 0.94. What is the ratio of the Imports (BoP, current US$) of Barbados in 2009 to that in 2010?
Give a very brief answer. 0.93. What is the ratio of the Imports (BoP, current US$) in Ethiopia in 2009 to that in 2010?
Offer a very short reply. 0.91. What is the ratio of the Imports (BoP, current US$) of Macedonia in 2009 to that in 2010?
Make the answer very short. 0.94. What is the ratio of the Imports (BoP, current US$) of Malaysia in 2009 to that in 2010?
Keep it short and to the point. 0.76. What is the difference between the highest and the second highest Imports (BoP, current US$) of Barbados?
Provide a short and direct response. 2.00e+08. What is the difference between the highest and the second highest Imports (BoP, current US$) in Ethiopia?
Keep it short and to the point. 3.13e+08. What is the difference between the highest and the second highest Imports (BoP, current US$) of Macedonia?
Your answer should be compact. 1.36e+09. What is the difference between the highest and the second highest Imports (BoP, current US$) of Malaysia?
Offer a very short reply. 1.08e+1. What is the difference between the highest and the lowest Imports (BoP, current US$) of Barbados?
Provide a short and direct response. 4.92e+08. What is the difference between the highest and the lowest Imports (BoP, current US$) of Ethiopia?
Offer a terse response. 5.02e+09. What is the difference between the highest and the lowest Imports (BoP, current US$) in Macedonia?
Your answer should be very brief. 3.63e+09. What is the difference between the highest and the lowest Imports (BoP, current US$) of Malaysia?
Keep it short and to the point. 5.89e+1. 